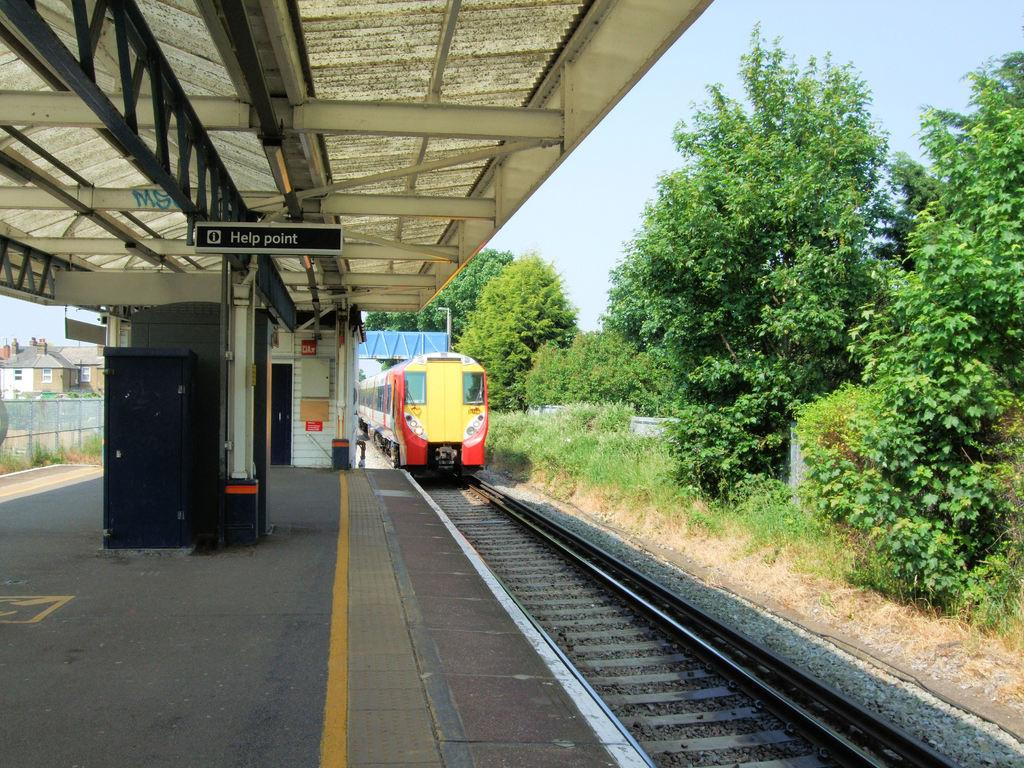<image>
Describe the image concisely. A red and yellow train approaching a sign that says Help Point. 